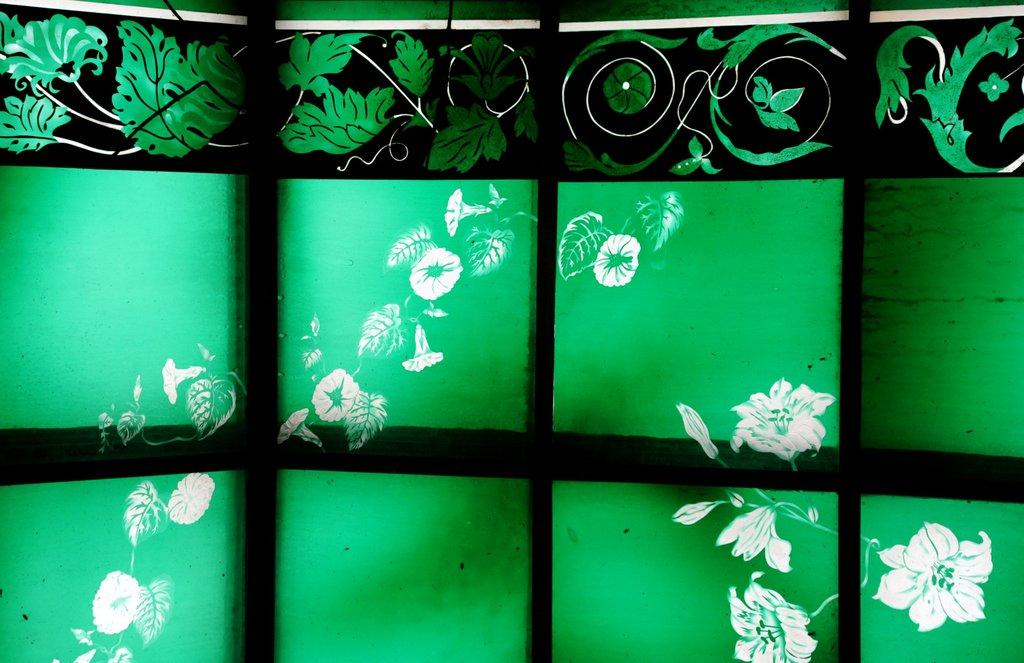What type of wall is visible in the image? There is a glass wall in the image. What type of produce is being used to express love in the image? There is no produce or expression of love present in the image; it only features a glass wall. 